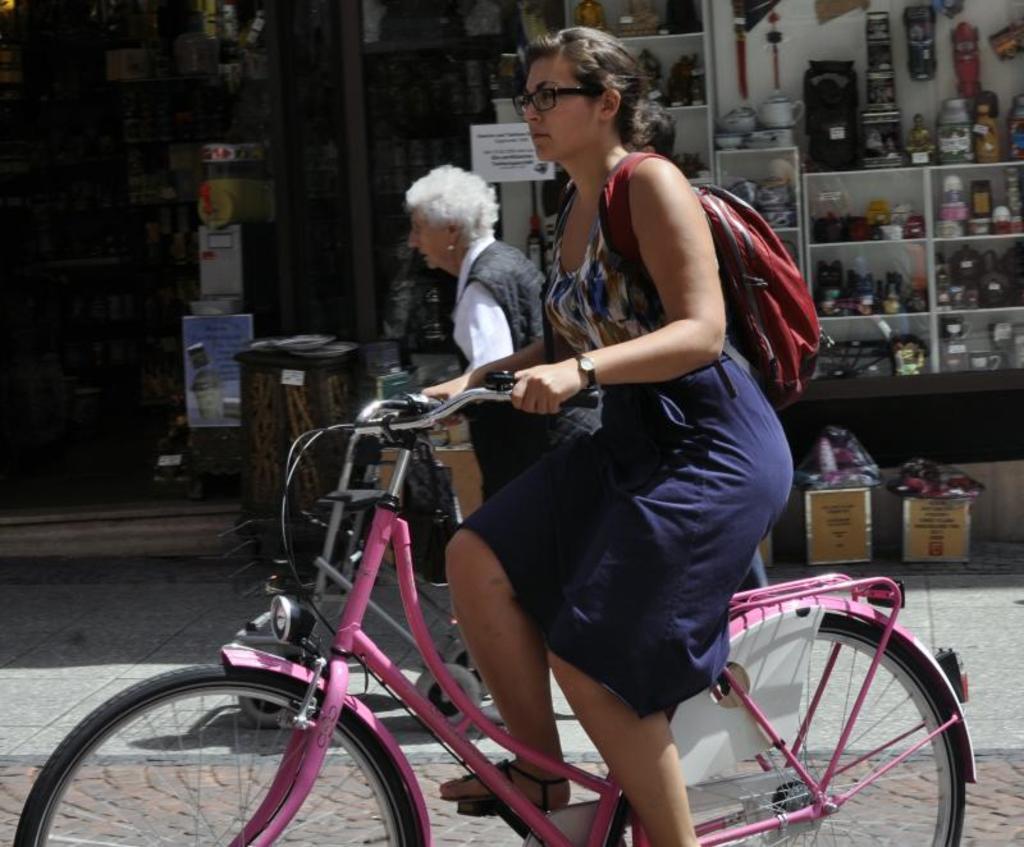Please provide a concise description of this image. In this image I can see two people. Among them one person is riding the bicycle. At the right to them there is a shop. 